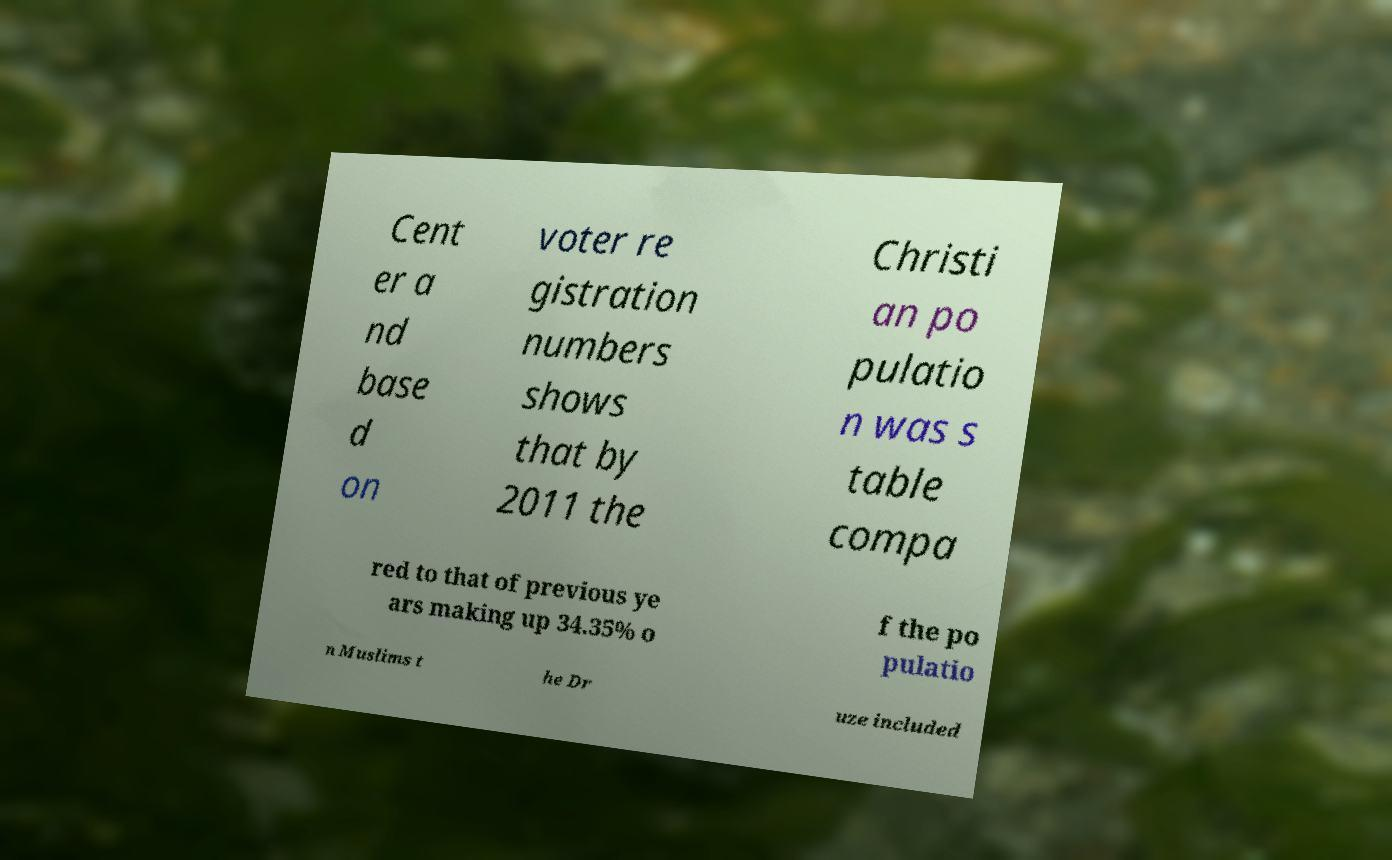For documentation purposes, I need the text within this image transcribed. Could you provide that? Cent er a nd base d on voter re gistration numbers shows that by 2011 the Christi an po pulatio n was s table compa red to that of previous ye ars making up 34.35% o f the po pulatio n Muslims t he Dr uze included 